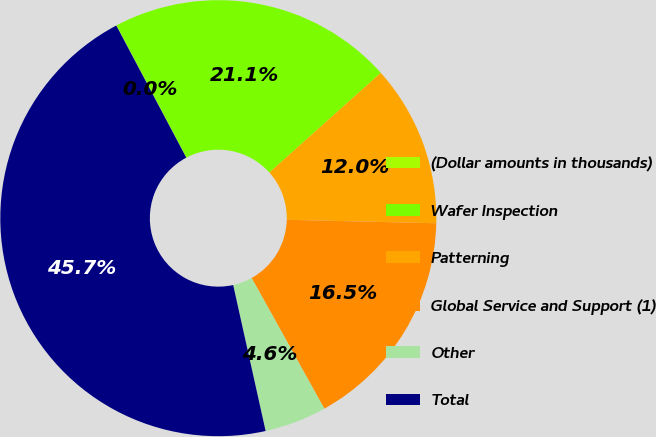Convert chart. <chart><loc_0><loc_0><loc_500><loc_500><pie_chart><fcel>(Dollar amounts in thousands)<fcel>Wafer Inspection<fcel>Patterning<fcel>Global Service and Support (1)<fcel>Other<fcel>Total<nl><fcel>0.03%<fcel>21.11%<fcel>11.98%<fcel>16.55%<fcel>4.6%<fcel>45.73%<nl></chart> 